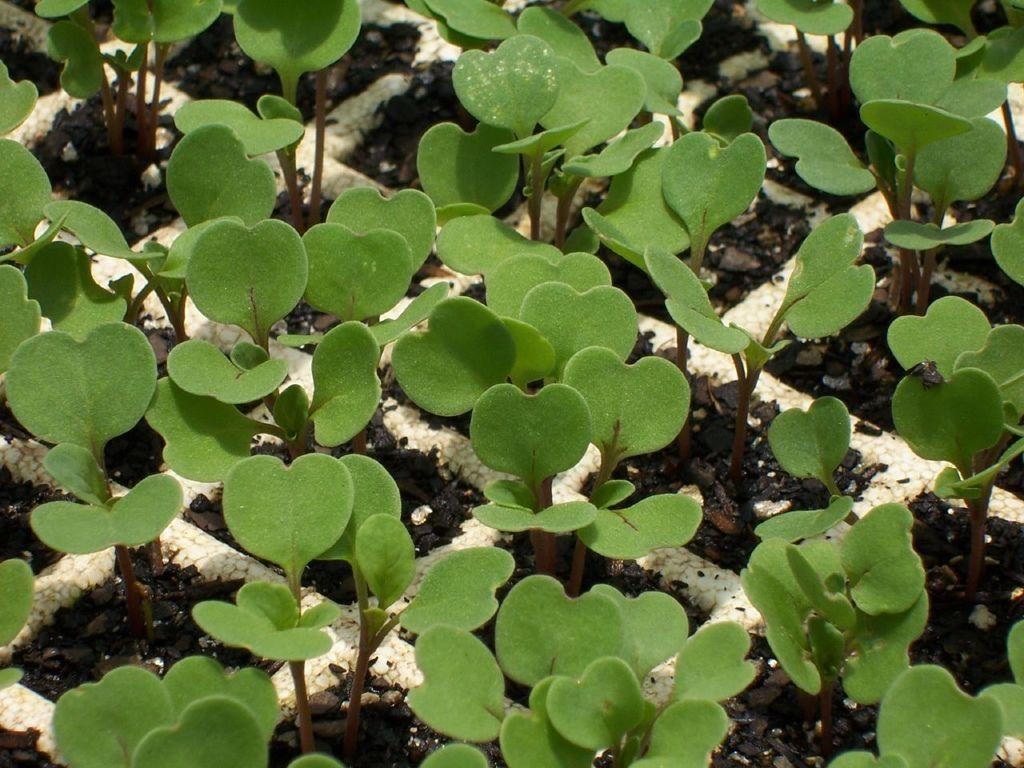What is the main feature of the image? The main feature of the image is a planting grid. What is the planting grid filled with? The planting grid contains soil. What is growing in the planting grid? There are plants in the planting grid. What type of hate can be seen in the image? There is no hate present in the image; it features a planting grid with soil and plants. How does the light affect the plants in the image? The image does not show any light source or its effect on the plants; it only shows the plants growing in the planting grid. 